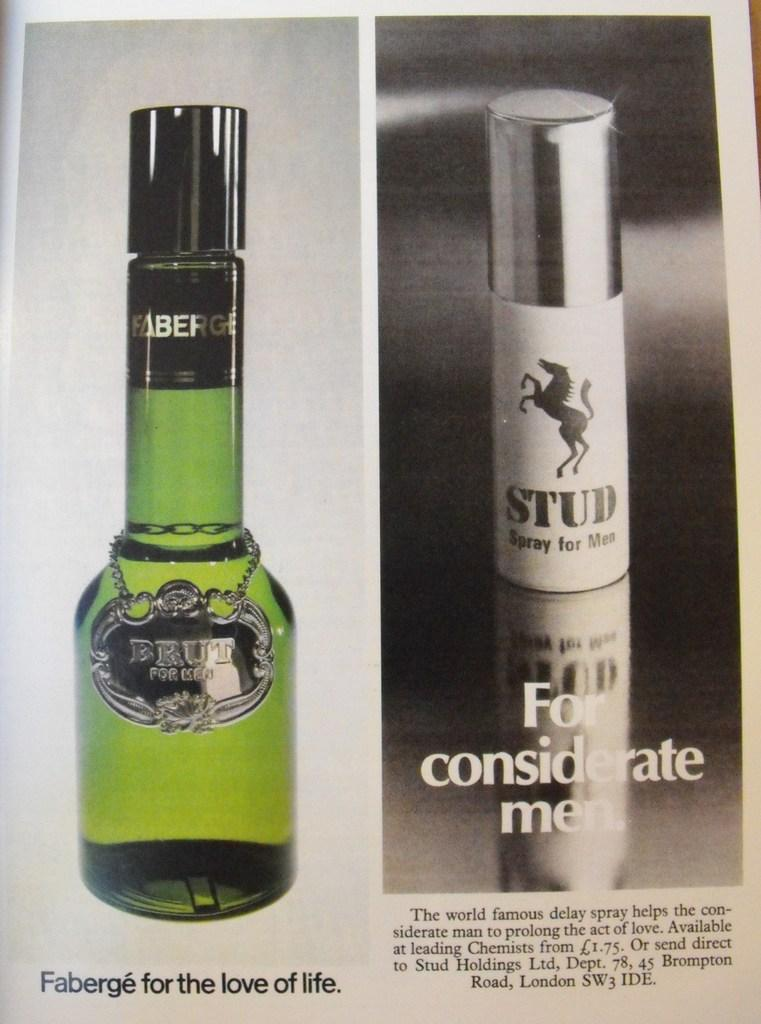What can be seen in the image? There is a newspaper in the image. What is placed on the newspaper? There is a bottle in the newspaper. What type of treatment is the man receiving on the sidewalk in the image? There is no man or sidewalk present in the image; it only features a newspaper with a bottle on it. 